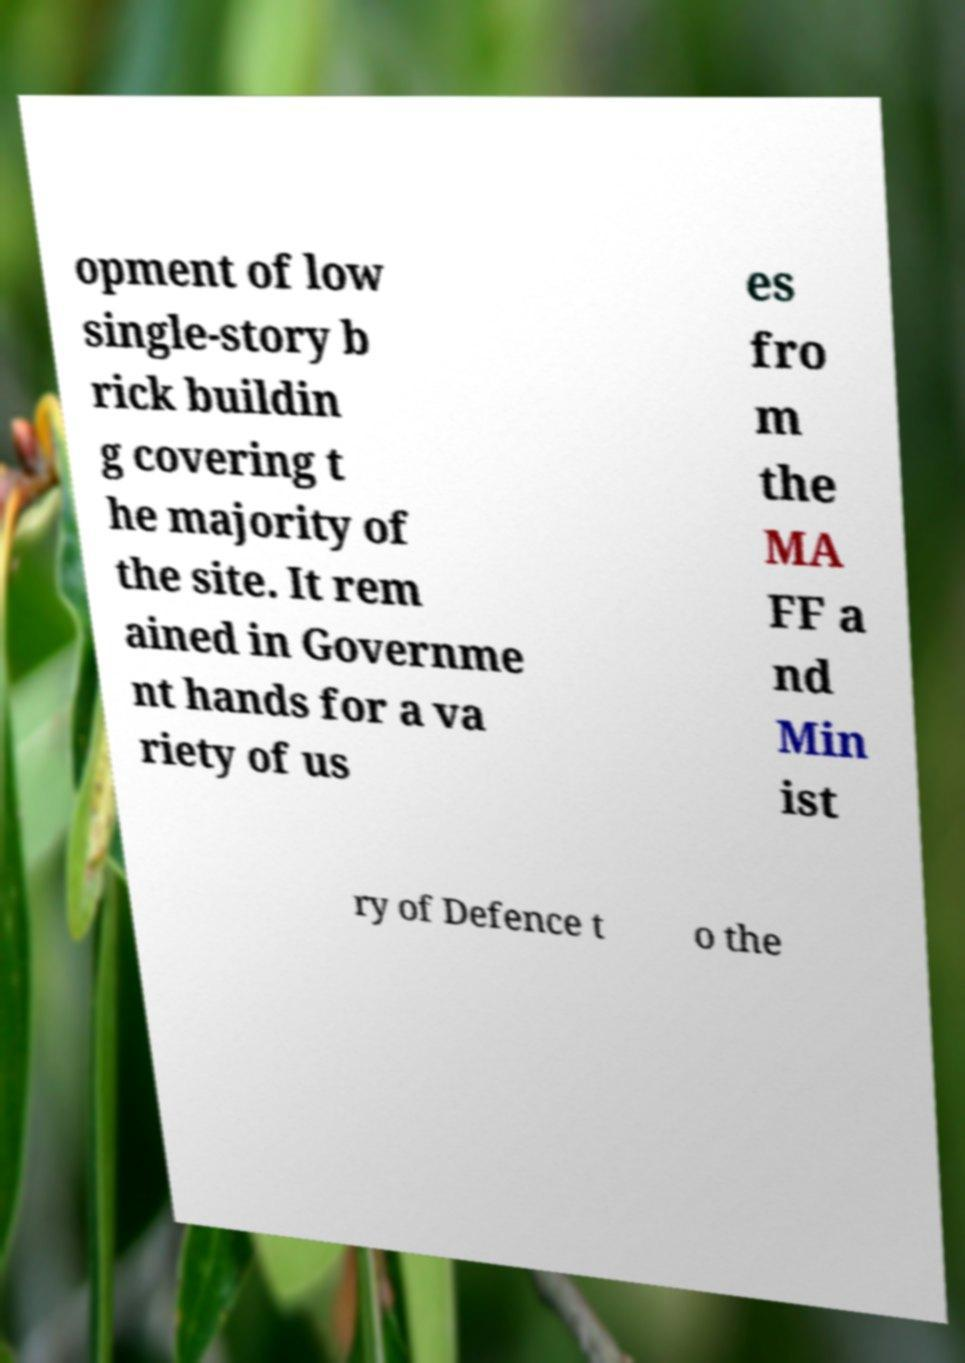Could you assist in decoding the text presented in this image and type it out clearly? opment of low single-story b rick buildin g covering t he majority of the site. It rem ained in Governme nt hands for a va riety of us es fro m the MA FF a nd Min ist ry of Defence t o the 